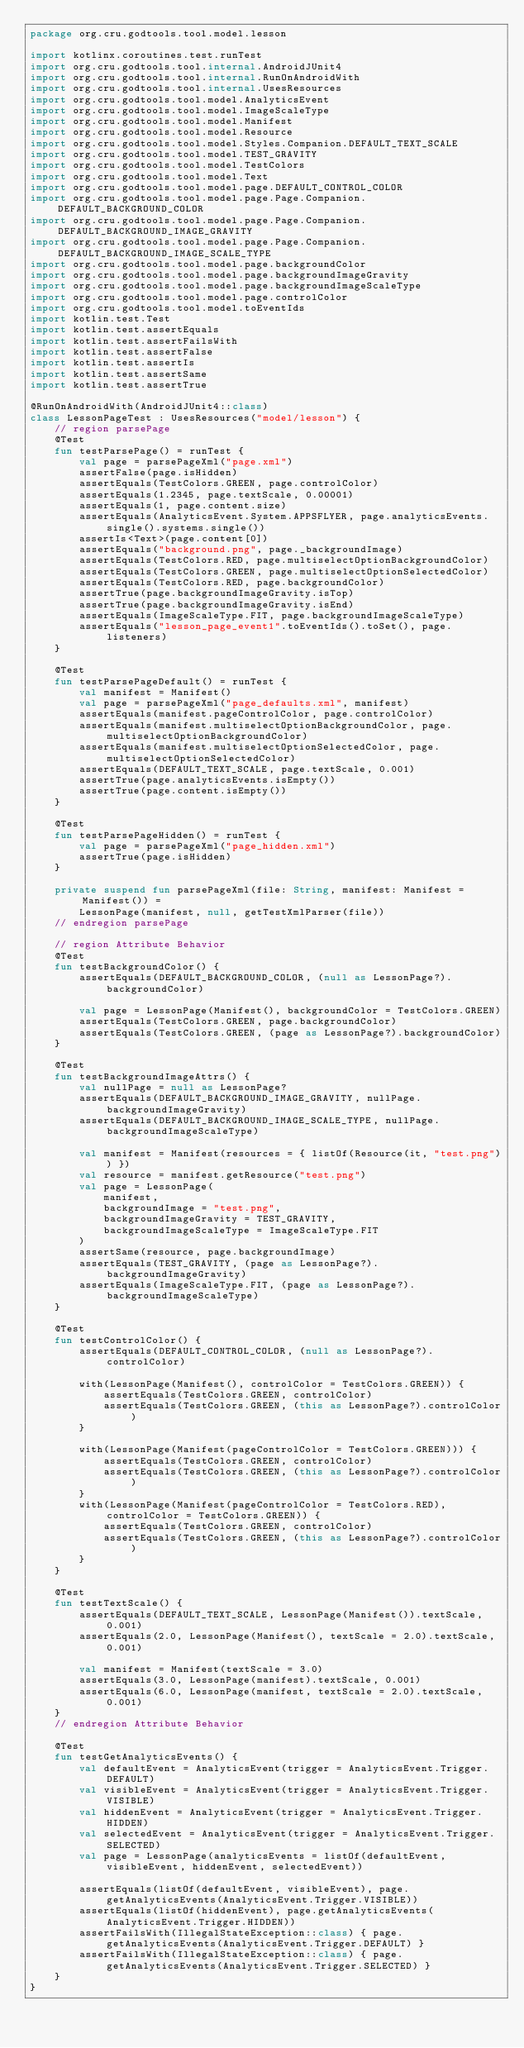<code> <loc_0><loc_0><loc_500><loc_500><_Kotlin_>package org.cru.godtools.tool.model.lesson

import kotlinx.coroutines.test.runTest
import org.cru.godtools.tool.internal.AndroidJUnit4
import org.cru.godtools.tool.internal.RunOnAndroidWith
import org.cru.godtools.tool.internal.UsesResources
import org.cru.godtools.tool.model.AnalyticsEvent
import org.cru.godtools.tool.model.ImageScaleType
import org.cru.godtools.tool.model.Manifest
import org.cru.godtools.tool.model.Resource
import org.cru.godtools.tool.model.Styles.Companion.DEFAULT_TEXT_SCALE
import org.cru.godtools.tool.model.TEST_GRAVITY
import org.cru.godtools.tool.model.TestColors
import org.cru.godtools.tool.model.Text
import org.cru.godtools.tool.model.page.DEFAULT_CONTROL_COLOR
import org.cru.godtools.tool.model.page.Page.Companion.DEFAULT_BACKGROUND_COLOR
import org.cru.godtools.tool.model.page.Page.Companion.DEFAULT_BACKGROUND_IMAGE_GRAVITY
import org.cru.godtools.tool.model.page.Page.Companion.DEFAULT_BACKGROUND_IMAGE_SCALE_TYPE
import org.cru.godtools.tool.model.page.backgroundColor
import org.cru.godtools.tool.model.page.backgroundImageGravity
import org.cru.godtools.tool.model.page.backgroundImageScaleType
import org.cru.godtools.tool.model.page.controlColor
import org.cru.godtools.tool.model.toEventIds
import kotlin.test.Test
import kotlin.test.assertEquals
import kotlin.test.assertFailsWith
import kotlin.test.assertFalse
import kotlin.test.assertIs
import kotlin.test.assertSame
import kotlin.test.assertTrue

@RunOnAndroidWith(AndroidJUnit4::class)
class LessonPageTest : UsesResources("model/lesson") {
    // region parsePage
    @Test
    fun testParsePage() = runTest {
        val page = parsePageXml("page.xml")
        assertFalse(page.isHidden)
        assertEquals(TestColors.GREEN, page.controlColor)
        assertEquals(1.2345, page.textScale, 0.00001)
        assertEquals(1, page.content.size)
        assertEquals(AnalyticsEvent.System.APPSFLYER, page.analyticsEvents.single().systems.single())
        assertIs<Text>(page.content[0])
        assertEquals("background.png", page._backgroundImage)
        assertEquals(TestColors.RED, page.multiselectOptionBackgroundColor)
        assertEquals(TestColors.GREEN, page.multiselectOptionSelectedColor)
        assertEquals(TestColors.RED, page.backgroundColor)
        assertTrue(page.backgroundImageGravity.isTop)
        assertTrue(page.backgroundImageGravity.isEnd)
        assertEquals(ImageScaleType.FIT, page.backgroundImageScaleType)
        assertEquals("lesson_page_event1".toEventIds().toSet(), page.listeners)
    }

    @Test
    fun testParsePageDefault() = runTest {
        val manifest = Manifest()
        val page = parsePageXml("page_defaults.xml", manifest)
        assertEquals(manifest.pageControlColor, page.controlColor)
        assertEquals(manifest.multiselectOptionBackgroundColor, page.multiselectOptionBackgroundColor)
        assertEquals(manifest.multiselectOptionSelectedColor, page.multiselectOptionSelectedColor)
        assertEquals(DEFAULT_TEXT_SCALE, page.textScale, 0.001)
        assertTrue(page.analyticsEvents.isEmpty())
        assertTrue(page.content.isEmpty())
    }

    @Test
    fun testParsePageHidden() = runTest {
        val page = parsePageXml("page_hidden.xml")
        assertTrue(page.isHidden)
    }

    private suspend fun parsePageXml(file: String, manifest: Manifest = Manifest()) =
        LessonPage(manifest, null, getTestXmlParser(file))
    // endregion parsePage

    // region Attribute Behavior
    @Test
    fun testBackgroundColor() {
        assertEquals(DEFAULT_BACKGROUND_COLOR, (null as LessonPage?).backgroundColor)

        val page = LessonPage(Manifest(), backgroundColor = TestColors.GREEN)
        assertEquals(TestColors.GREEN, page.backgroundColor)
        assertEquals(TestColors.GREEN, (page as LessonPage?).backgroundColor)
    }

    @Test
    fun testBackgroundImageAttrs() {
        val nullPage = null as LessonPage?
        assertEquals(DEFAULT_BACKGROUND_IMAGE_GRAVITY, nullPage.backgroundImageGravity)
        assertEquals(DEFAULT_BACKGROUND_IMAGE_SCALE_TYPE, nullPage.backgroundImageScaleType)

        val manifest = Manifest(resources = { listOf(Resource(it, "test.png")) })
        val resource = manifest.getResource("test.png")
        val page = LessonPage(
            manifest,
            backgroundImage = "test.png",
            backgroundImageGravity = TEST_GRAVITY,
            backgroundImageScaleType = ImageScaleType.FIT
        )
        assertSame(resource, page.backgroundImage)
        assertEquals(TEST_GRAVITY, (page as LessonPage?).backgroundImageGravity)
        assertEquals(ImageScaleType.FIT, (page as LessonPage?).backgroundImageScaleType)
    }

    @Test
    fun testControlColor() {
        assertEquals(DEFAULT_CONTROL_COLOR, (null as LessonPage?).controlColor)

        with(LessonPage(Manifest(), controlColor = TestColors.GREEN)) {
            assertEquals(TestColors.GREEN, controlColor)
            assertEquals(TestColors.GREEN, (this as LessonPage?).controlColor)
        }

        with(LessonPage(Manifest(pageControlColor = TestColors.GREEN))) {
            assertEquals(TestColors.GREEN, controlColor)
            assertEquals(TestColors.GREEN, (this as LessonPage?).controlColor)
        }
        with(LessonPage(Manifest(pageControlColor = TestColors.RED), controlColor = TestColors.GREEN)) {
            assertEquals(TestColors.GREEN, controlColor)
            assertEquals(TestColors.GREEN, (this as LessonPage?).controlColor)
        }
    }

    @Test
    fun testTextScale() {
        assertEquals(DEFAULT_TEXT_SCALE, LessonPage(Manifest()).textScale, 0.001)
        assertEquals(2.0, LessonPage(Manifest(), textScale = 2.0).textScale, 0.001)

        val manifest = Manifest(textScale = 3.0)
        assertEquals(3.0, LessonPage(manifest).textScale, 0.001)
        assertEquals(6.0, LessonPage(manifest, textScale = 2.0).textScale, 0.001)
    }
    // endregion Attribute Behavior

    @Test
    fun testGetAnalyticsEvents() {
        val defaultEvent = AnalyticsEvent(trigger = AnalyticsEvent.Trigger.DEFAULT)
        val visibleEvent = AnalyticsEvent(trigger = AnalyticsEvent.Trigger.VISIBLE)
        val hiddenEvent = AnalyticsEvent(trigger = AnalyticsEvent.Trigger.HIDDEN)
        val selectedEvent = AnalyticsEvent(trigger = AnalyticsEvent.Trigger.SELECTED)
        val page = LessonPage(analyticsEvents = listOf(defaultEvent, visibleEvent, hiddenEvent, selectedEvent))

        assertEquals(listOf(defaultEvent, visibleEvent), page.getAnalyticsEvents(AnalyticsEvent.Trigger.VISIBLE))
        assertEquals(listOf(hiddenEvent), page.getAnalyticsEvents(AnalyticsEvent.Trigger.HIDDEN))
        assertFailsWith(IllegalStateException::class) { page.getAnalyticsEvents(AnalyticsEvent.Trigger.DEFAULT) }
        assertFailsWith(IllegalStateException::class) { page.getAnalyticsEvents(AnalyticsEvent.Trigger.SELECTED) }
    }
}
</code> 